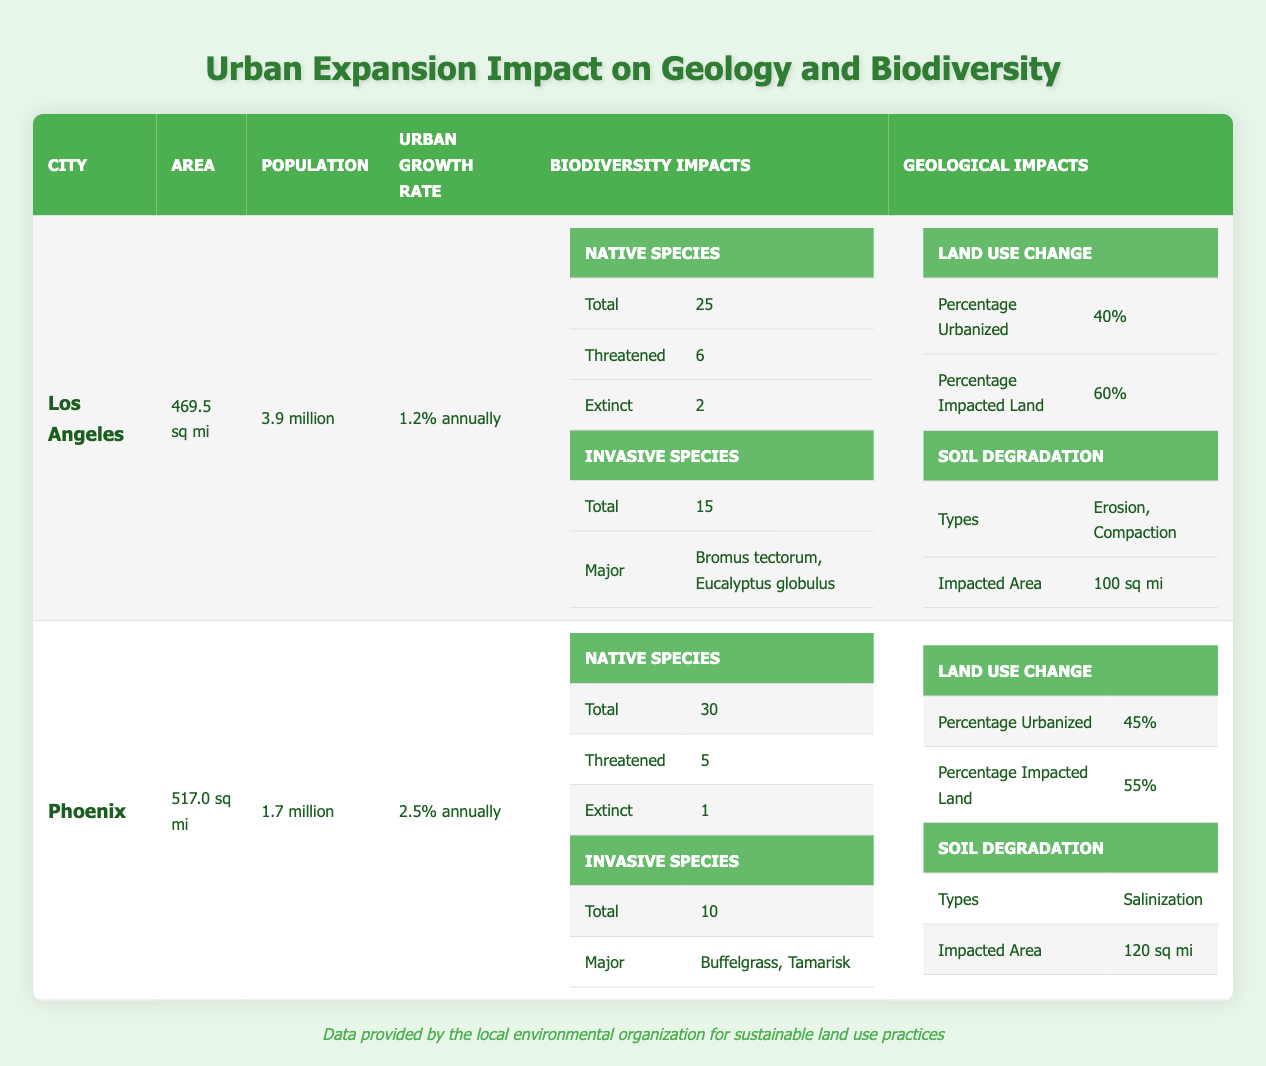What is the population of the City of Los Angeles? The table shows that the population of the City of Los Angeles is listed as 3.9 million under the Population column.
Answer: 3.9 million What is the urban growth rate for the City of Phoenix? In the table, the urban growth rate specifically for the City of Phoenix is stated as 2.5% annually.
Answer: 2.5% annually How many total native species are reported in Los Angeles? A closer look at the biodiversity impacts for Los Angeles reveals that the total number of native species is 25.
Answer: 25 Which city has a higher percentage of urbanized land: Los Angeles or Phoenix? By comparing the data, the percentage urbanized for Los Angeles is 40% while for Phoenix it is 45%. Therefore, Phoenix has a higher percentage of urbanized land.
Answer: Phoenix Is it true that the City of Phoenix has more threatened native species than the City of Los Angeles? The table indicates that Phoenix has 5 threatened native species while Los Angeles has 6. Therefore, the statement is false.
Answer: No What is the total number of invasive species in both cities combined? The City of Los Angeles has 15 invasive species and the City of Phoenix has 10. So when added together: 15 + 10 = 25 invasive species in total.
Answer: 25 How much greater is the impacted area due to soil degradation in Phoenix compared to Los Angeles? The impacted area of soil degradation for Phoenix is 120 sq mi and for Los Angeles it is 100 sq mi. To find the difference: 120 - 100 = 20 sq mi greater in Phoenix.
Answer: 20 sq mi What percentage of impacted land is in the City of Los Angeles? From the data, the percentage impacted land for the City of Los Angeles is shown as 60%.
Answer: 60% Which city has a type of soil degradation that is different from the other city? The City of Los Angeles experiences erosion and compaction, while Phoenix is facing salinization. Since these types are unique to each city, the answer is that each city has a different type of soil degradation.
Answer: Yes 